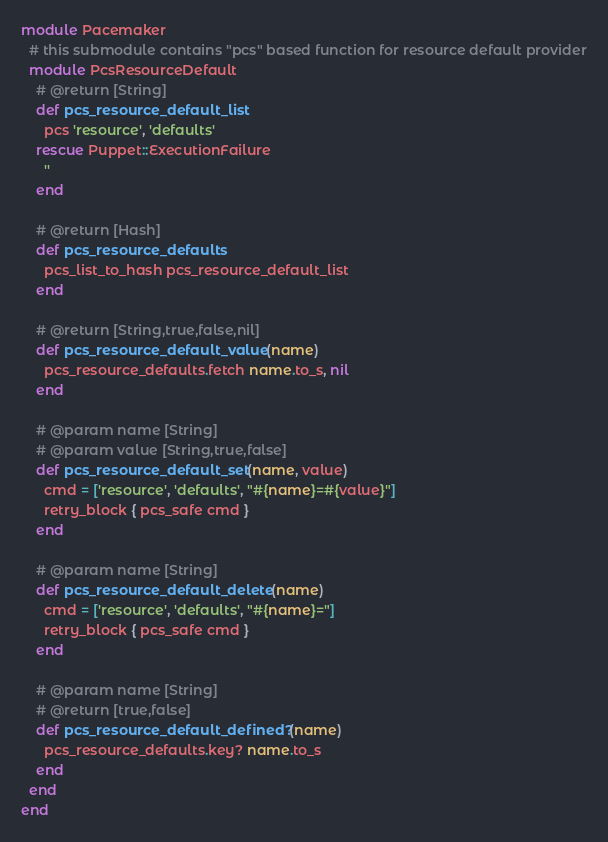<code> <loc_0><loc_0><loc_500><loc_500><_Ruby_>module Pacemaker
  # this submodule contains "pcs" based function for resource default provider
  module PcsResourceDefault
    # @return [String]
    def pcs_resource_default_list
      pcs 'resource', 'defaults'
    rescue Puppet::ExecutionFailure
      ''
    end

    # @return [Hash]
    def pcs_resource_defaults
      pcs_list_to_hash pcs_resource_default_list
    end

    # @return [String,true,false,nil]
    def pcs_resource_default_value(name)
      pcs_resource_defaults.fetch name.to_s, nil
    end

    # @param name [String]
    # @param value [String,true,false]
    def pcs_resource_default_set(name, value)
      cmd = ['resource', 'defaults', "#{name}=#{value}"]
      retry_block { pcs_safe cmd }
    end

    # @param name [String]
    def pcs_resource_default_delete(name)
      cmd = ['resource', 'defaults', "#{name}="]
      retry_block { pcs_safe cmd }
    end

    # @param name [String]
    # @return [true,false]
    def pcs_resource_default_defined?(name)
      pcs_resource_defaults.key? name.to_s
    end
  end
end
</code> 